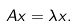Convert formula to latex. <formula><loc_0><loc_0><loc_500><loc_500>A x = \lambda x .</formula> 